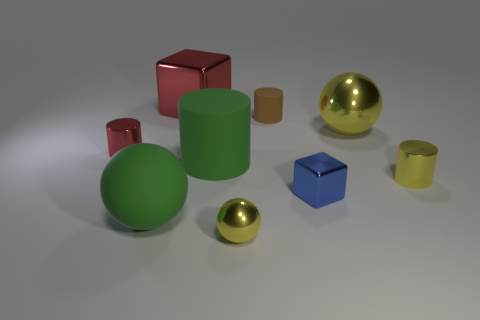Is there a cylinder of the same color as the big matte ball?
Your response must be concise. Yes. What is the color of the small thing that is the same shape as the large red metal object?
Offer a very short reply. Blue. Are there more red blocks in front of the small shiny ball than large green matte objects that are on the right side of the tiny brown rubber object?
Offer a very short reply. No. How many other things are the same shape as the tiny red metallic object?
Offer a terse response. 3. Is there a block to the left of the large sphere to the right of the tiny blue cube?
Your response must be concise. Yes. How many small yellow metal cylinders are there?
Give a very brief answer. 1. There is a large rubber cylinder; is its color the same as the matte object in front of the blue block?
Provide a succinct answer. Yes. Are there more large brown blocks than shiny blocks?
Provide a succinct answer. No. Is there anything else that has the same color as the tiny matte object?
Offer a terse response. No. What number of other things are the same size as the blue metallic block?
Offer a terse response. 4. 